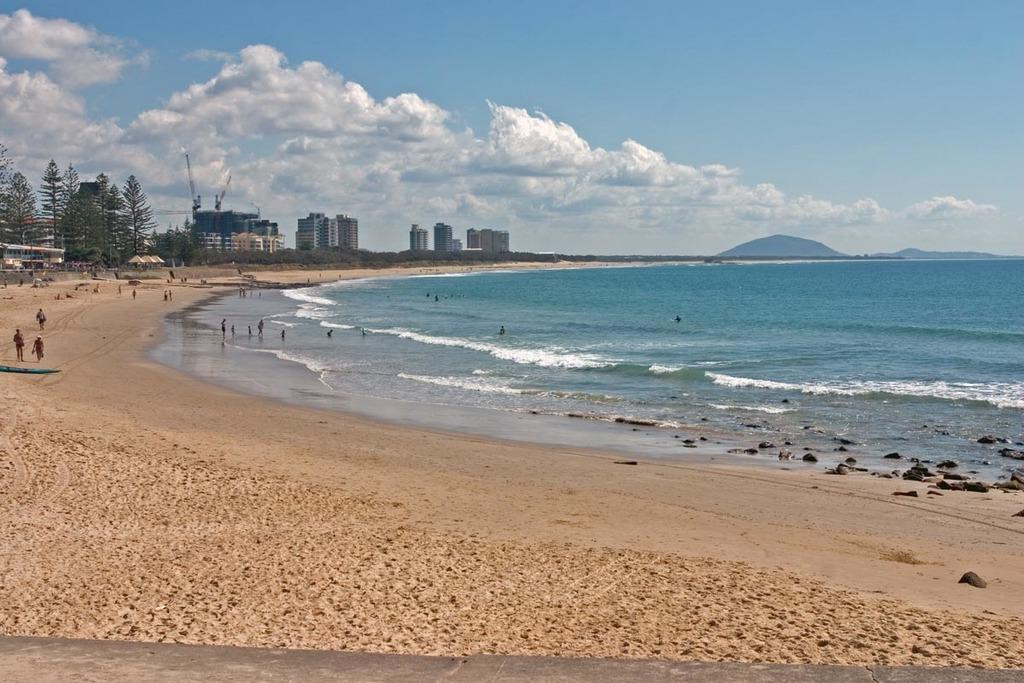What type of natural elements can be seen in the image? There are stones, water, sand, trees, and mountains visible in the image. What are the people in the image doing? The people in the image are on sand, which suggests they might be at a beach or shore. What objects are present in the image to provide shade or protection from the sun? There are umbrellas in the image. What type of structures can be seen in the image? There are buildings in the image. What is visible in the background of the image? The sky is visible in the background of the image, with clouds present. What type of brass instrument is being played by the person in the image? There is no brass instrument or person playing an instrument present in the image. What type of cord is being used to tie the string to the tree in the image? There is no cord or string tied to a tree in the image. 